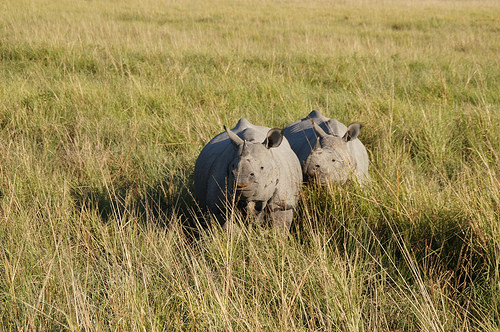<image>
Is the rhino behind the rhino? No. The rhino is not behind the rhino. From this viewpoint, the rhino appears to be positioned elsewhere in the scene. 